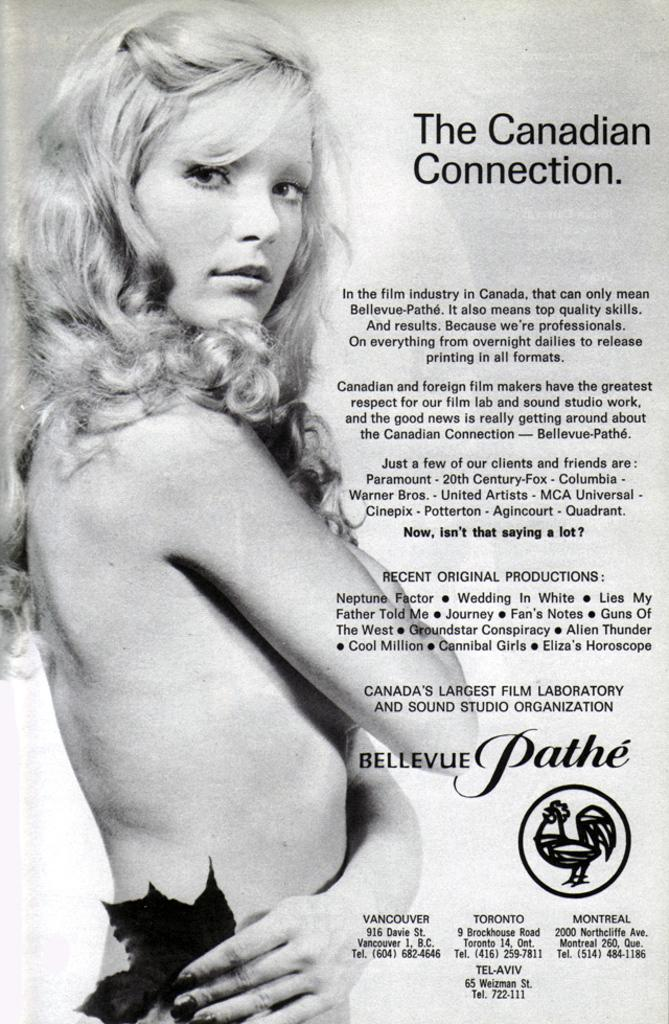What is present on the poster in the image? There is a poster in the image that contains images and text. Can you describe the images on the poster? Unfortunately, the specific images on the poster cannot be described without more information. What type of information is conveyed through the text on the poster? The content of the text on the poster cannot be determined without more information. How does the snow affect the cause of the arithmetic problem in the image? There is no snow, cause, or arithmetic problem present in the image. 